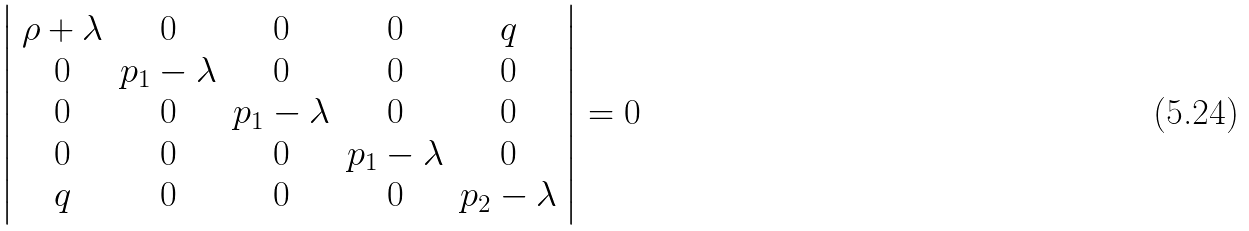<formula> <loc_0><loc_0><loc_500><loc_500>\left | \begin{array} { c c c c c } \rho + \lambda & 0 & 0 & 0 & q \\ 0 & p _ { 1 } - \lambda & 0 & 0 & 0 \\ 0 & 0 & p _ { 1 } - \lambda & 0 & 0 \\ 0 & 0 & 0 & p _ { 1 } - \lambda & 0 \\ q & 0 & 0 & 0 & p _ { 2 } - \lambda \end{array} \right | = 0</formula> 